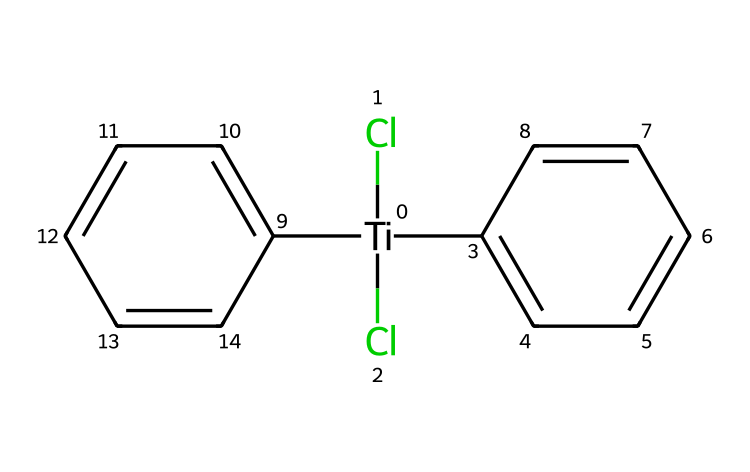What is the central metal atom in titanocene dichloride? The chemical structure shows the titanium atom, denoted by [Ti], as the central metal surrounded by chlorines and cyclopentadienyl rings.
Answer: titanium How many chlorine atoms are present in titanocene dichloride? From the SMILES representation, there are two chlorine atoms indicated by (Cl)(Cl) connected to the titanium in the structure.
Answer: two What type of bonds are formed between titanium and chlorine in titanocene dichloride? The bonds between titanium and chlorine atoms are ionic or coordinate covalent, as titanium typically donates electrons to bind with chlorine.
Answer: ionic Which functional groups are evident in the structure of titanocene dichloride? The structure includes cyclopentadienyl rings, characteristic of organometallic compounds, which are represented by C1=CC=CC=C1, indicating aliphatic groups.
Answer: cyclopentadienyl rings What is the total number of carbon atoms in titanocene dichloride? The structure contains two cyclopentadienyl rings, each with five carbon atoms (C), resulting in a total of 10 carbon atoms.
Answer: ten How do the cyclopentadienyl rings influence the reactivity of titanocene dichloride? The cyclopentadienyl rings contribute to the stability and reactivity of the complex, allowing for π-backbonding and strong ligand interactions with titanium.
Answer: π-backbonding What type of organometallic compound is titanocene dichloride classified as? Given its composition and the presence of a metal-carbon bond with titanium coordinating with cyclopentadienyl rings, it is classified as a metallocene.
Answer: metallocene 